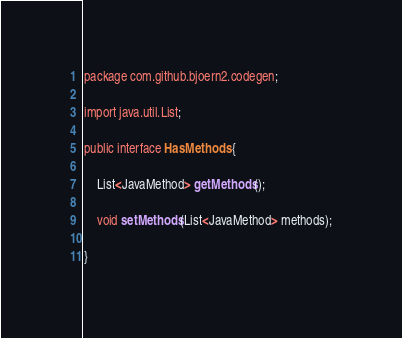<code> <loc_0><loc_0><loc_500><loc_500><_Java_>package com.github.bjoern2.codegen;

import java.util.List;

public interface HasMethods {

	List<JavaMethod> getMethods();
	
	void setMethods(List<JavaMethod> methods);
	
}
</code> 